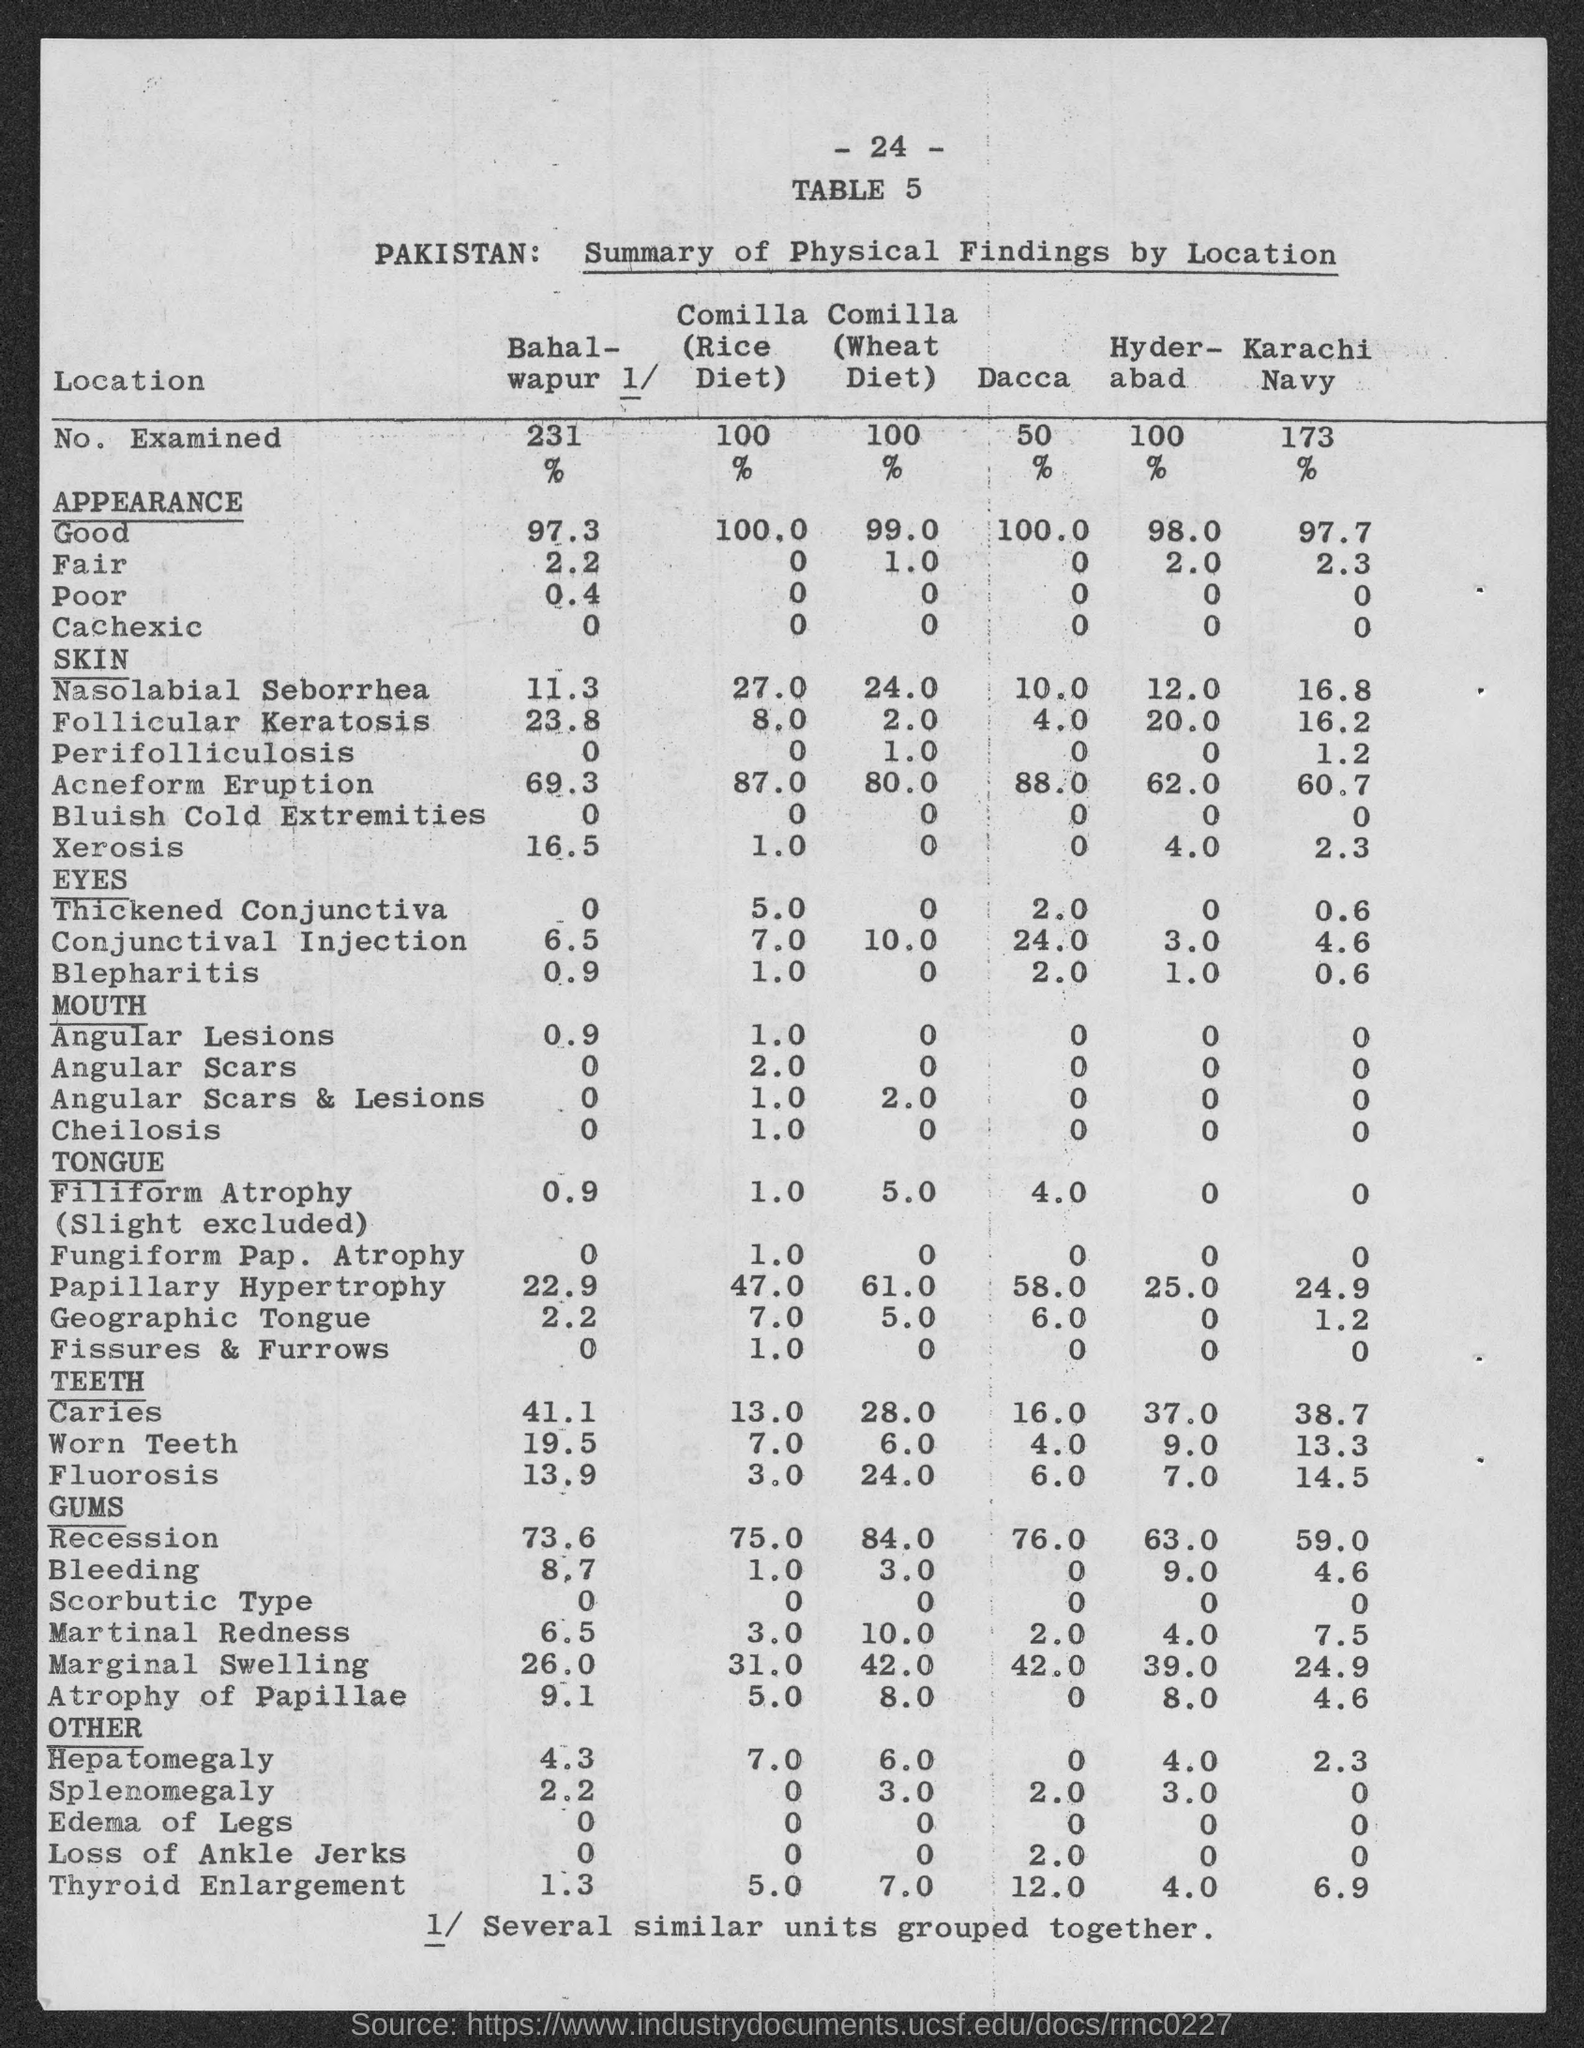Give some essential details in this illustration. The number of examined individuals in Karachi for the Navy is 173. The number of children examined in Dhaka is 50. The number of examined in Hyderabad is 100. There have been 231 examinations in Bahalwapur. The Rice Diet Program, also known as the Comila Diet, has examined a total of 100 individuals. 